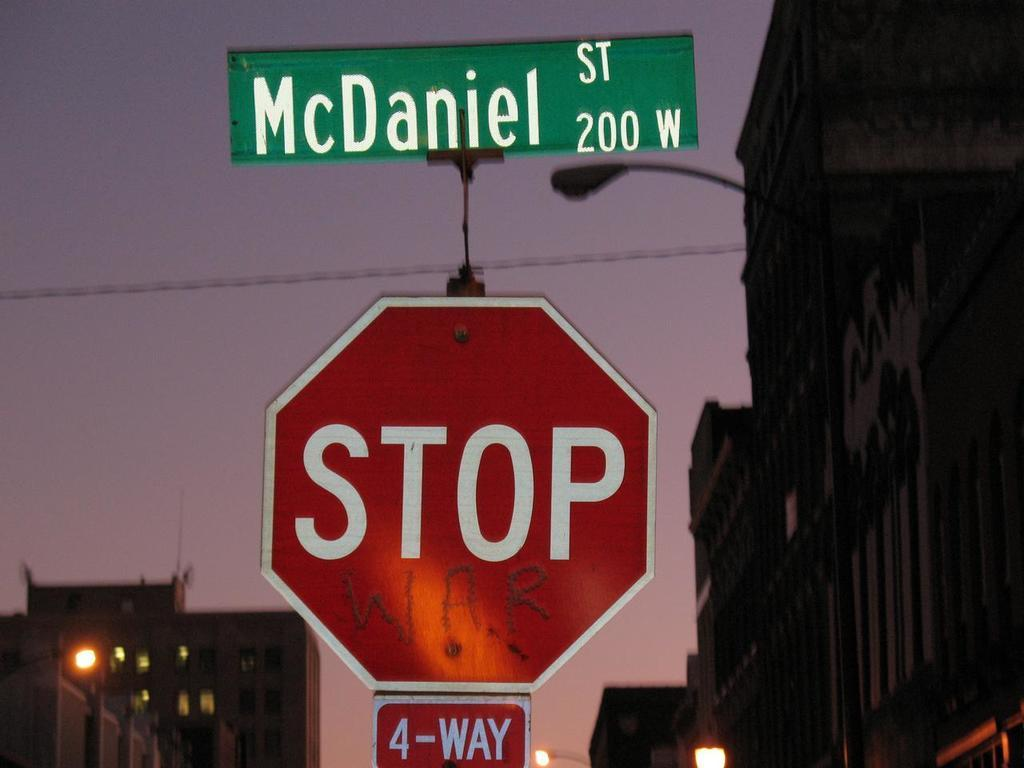<image>
Provide a brief description of the given image. Three signs on the street named McDaniel St., stop sign with 4-way. 